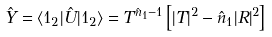Convert formula to latex. <formula><loc_0><loc_0><loc_500><loc_500>\hat { Y } = \langle 1 _ { 2 } | \hat { U } | 1 _ { 2 } \rangle = T ^ { \hat { n } _ { 1 } - 1 } \left [ | T | ^ { 2 } - \hat { n } _ { 1 } | R | ^ { 2 } \right ]</formula> 